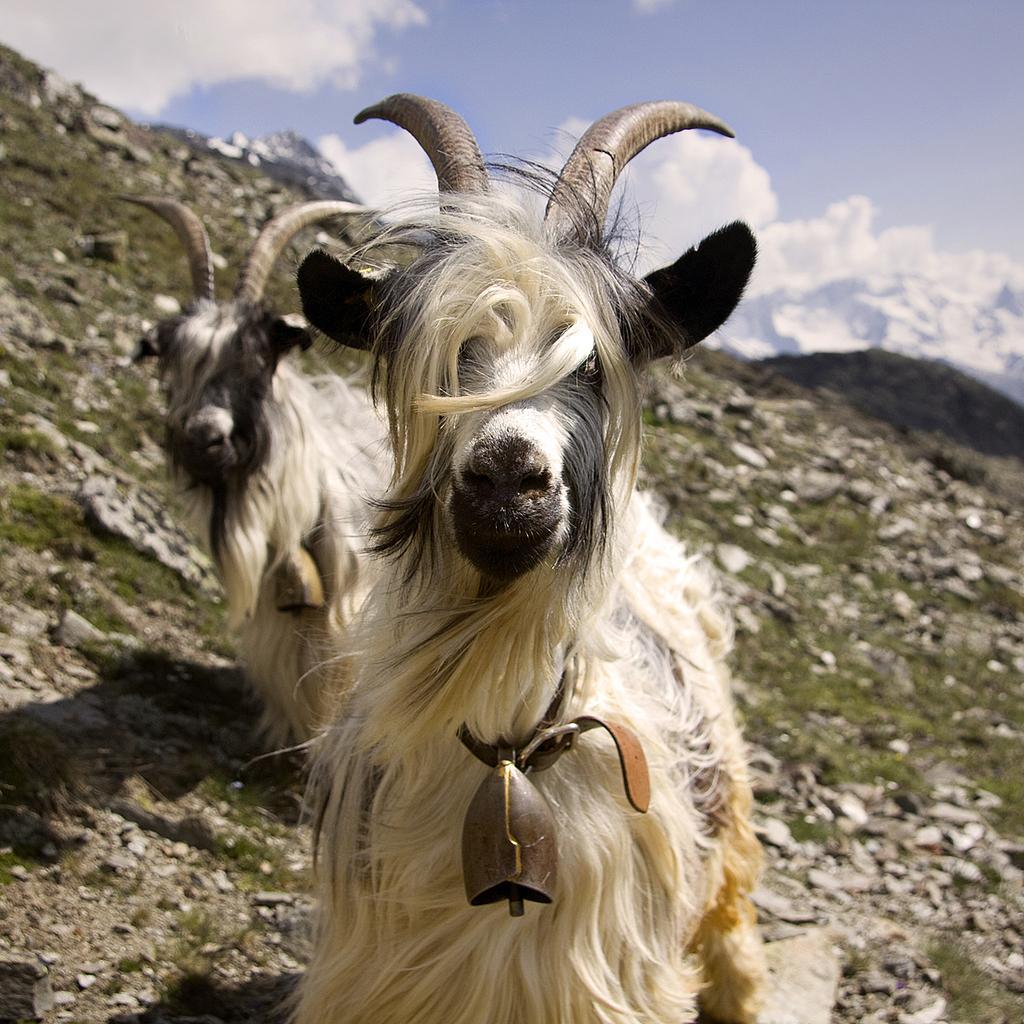Can you describe this image briefly? In this Image I can see two animals are on the ground. These animals are in black and cream color. And I can see the belt to these animals. In the back there are clouds and the sky. 